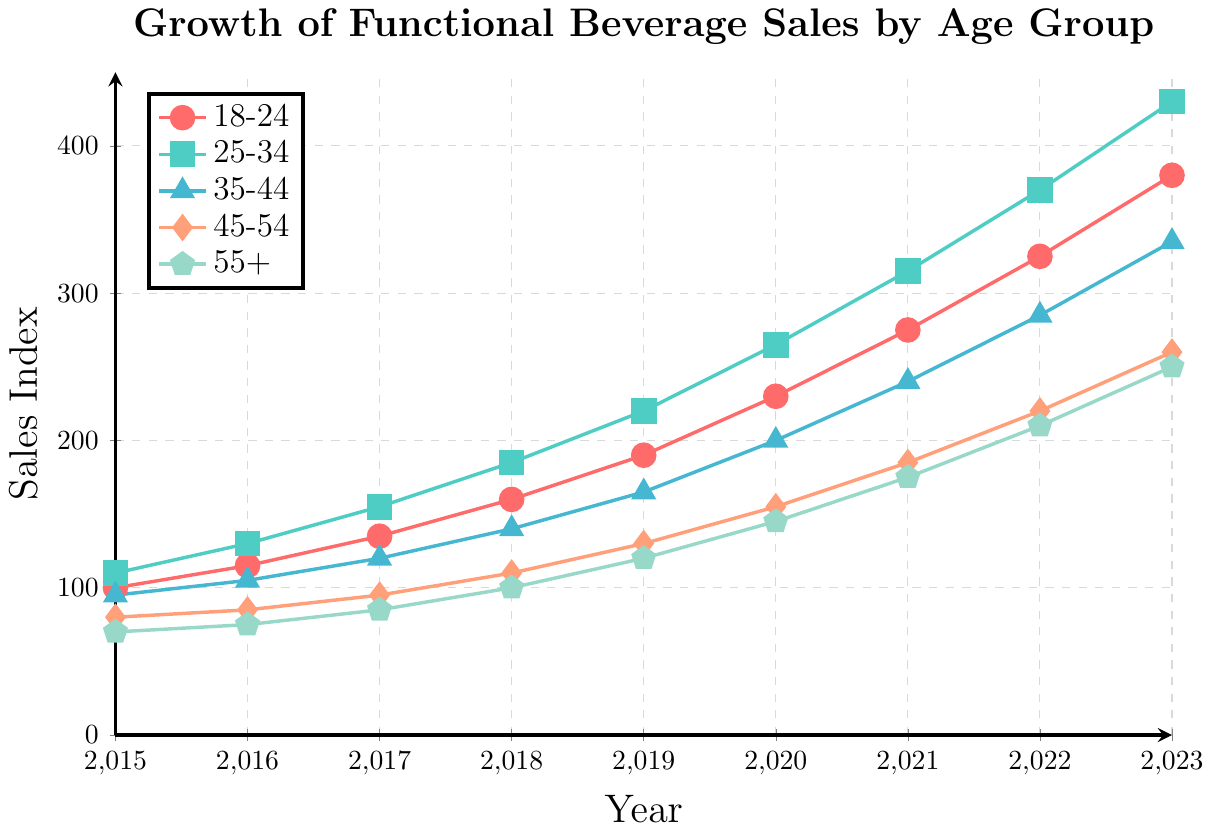Which age group had the highest sales in 2023? To determine the highest sales in 2023, we look at the y-values for each age group for the year 2023. The 25-34 age group reached 430, which is the highest among all groups.
Answer: 25-34 What is the overall trend in sales from 2015 to 2023 for the 18-24 age group? To identify the trend, observe the progression of sales values for the 18-24 age group from 2015 (100) to 2023 (380). The sales consistently increase year by year.
Answer: Increasing How much did the sales index for the 35-44 age group increase from 2015 to 2023? The sales index for the 35-44 age group was 95 in 2015 and 335 in 2023. The increase is calculated by the difference: 335 - 95 = 240.
Answer: 240 Between 2020 and 2021, which age group saw the largest increase in sales index? Calculate the difference in sales index for each age group between 2020 and 2021: 
18-24 (275 - 230 = 45), 
25-34 (315 - 265 = 50), 
35-44 (240 - 200 = 40), 
45-54 (185 - 155 = 30),
55+ (175 - 145 = 30). 
The largest increase is observed in the 25-34 age group with an increase of 50.
Answer: 25-34 By what percentage did the sales index for the 45-54 age group grow from 2017 to 2018? The sales index for 45-54 was 95 in 2017 and 110 in 2018. The percentage growth is calculated as ((110 - 95) / 95) * 100 ≈ 15.79%.
Answer: 15.79% Which two age groups had the closest sales values in 2017? We compare the sales values in 2017 for all groups: 
18-24 (135), 
25-34 (155), 
35-44 (120), 
45-54 (95), 
55+ (85). 
The closest sales values are for the age groups 45-54 (95) and 55+ (85) with a difference of 10.
Answer: 45-54 and 55+ What is the average annual growth in sales index for the 55+ age group from 2015 to 2023? The sales index for the 55+ group in 2015 was 70, and in 2023 it was 250. The total growth is 250 - 70 = 180 over 8 years. The average annual growth is 180 / 8 = 22.5.
Answer: 22.5 Compare the sales index in 2020 for the 18-24 and 35-44 age groups. Which one is higher and by how much? The sales index in 2020 for the 18-24 age group is 230 and for the 35-44 age group is 200. The 18-24 age group is higher by 230 - 200 = 30.
Answer: 18-24 by 30 